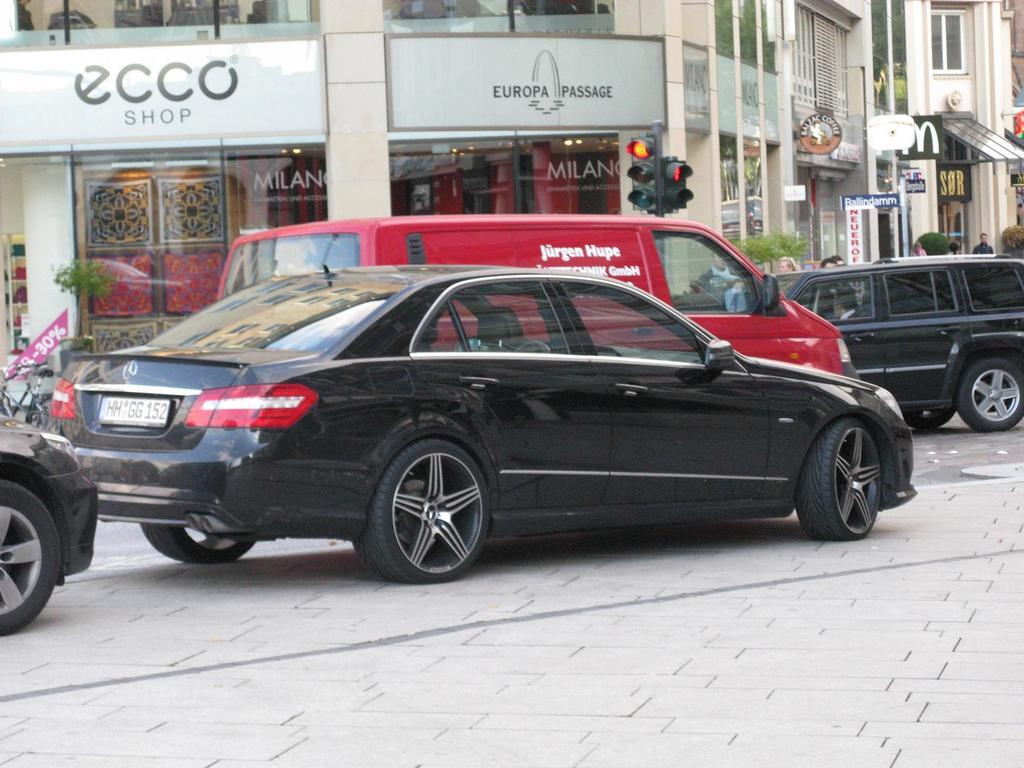What type of vehicles can be seen on the road in the image? There are cars on the road in the image. What can be seen in the background of the image? There are buildings, banners, and traffic lights in the background of the image. What is located on the left side of the image? There is a plant and a bicycle on the left side of the image. How many dogs are present in the image? There are no dogs present in the image. What type of cattle can be seen grazing in the background of the image? There is no cattle present in the image; it only features cars, buildings, banners, traffic lights, a plant, and a bicycle. 